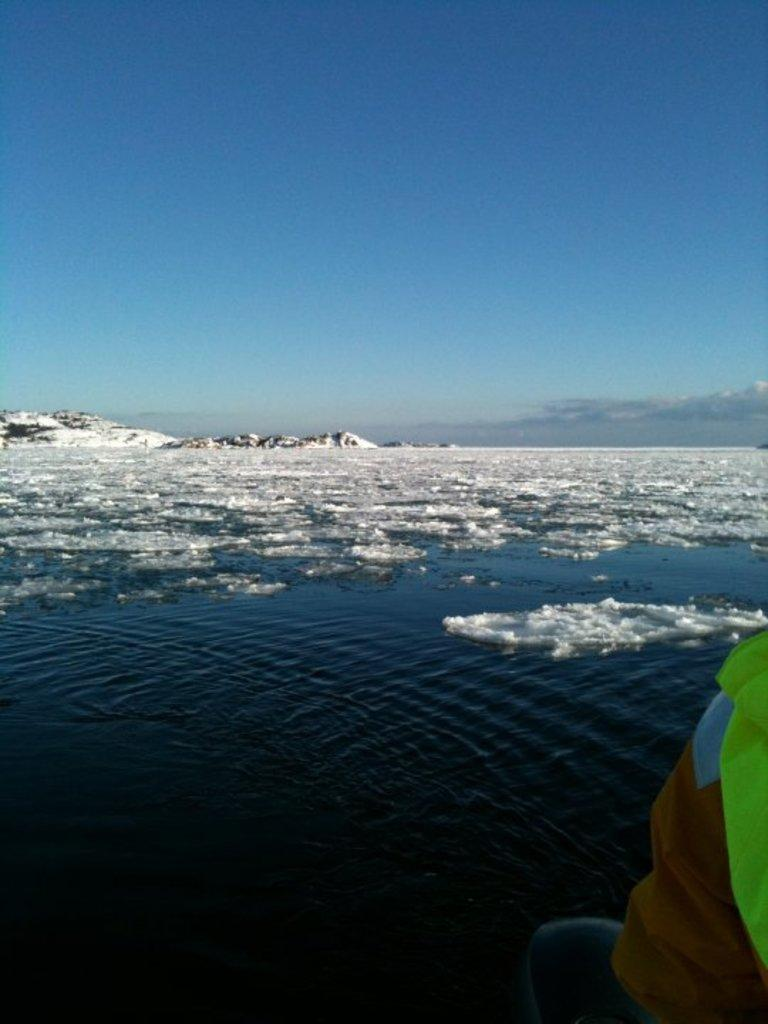What is the main feature of the image? The main feature of the image is a water surface that is partially covered with ice. Can you describe the person in the image? There is a person on the right side of the image. What can be seen in the background of the image? There is a snow mountain in the background of the image. What is the taste of the basketball in the image? There is no basketball present in the image, so it cannot be tasted or have a taste. 